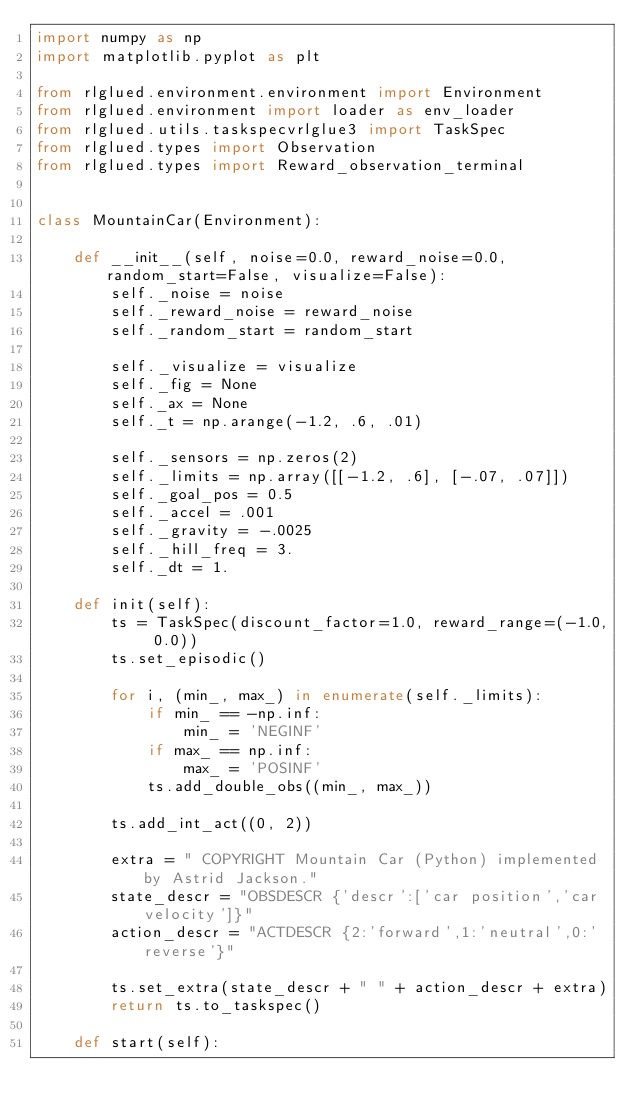<code> <loc_0><loc_0><loc_500><loc_500><_Python_>import numpy as np
import matplotlib.pyplot as plt

from rlglued.environment.environment import Environment
from rlglued.environment import loader as env_loader
from rlglued.utils.taskspecvrlglue3 import TaskSpec
from rlglued.types import Observation
from rlglued.types import Reward_observation_terminal


class MountainCar(Environment):

    def __init__(self, noise=0.0, reward_noise=0.0, random_start=False, visualize=False):
        self._noise = noise
        self._reward_noise = reward_noise
        self._random_start = random_start

        self._visualize = visualize
        self._fig = None
        self._ax = None
        self._t = np.arange(-1.2, .6, .01)

        self._sensors = np.zeros(2)
        self._limits = np.array([[-1.2, .6], [-.07, .07]])
        self._goal_pos = 0.5
        self._accel = .001
        self._gravity = -.0025
        self._hill_freq = 3.
        self._dt = 1.

    def init(self):
        ts = TaskSpec(discount_factor=1.0, reward_range=(-1.0, 0.0))
        ts.set_episodic()

        for i, (min_, max_) in enumerate(self._limits):
            if min_ == -np.inf:
                min_ = 'NEGINF'
            if max_ == np.inf:
                max_ = 'POSINF'
            ts.add_double_obs((min_, max_))

        ts.add_int_act((0, 2))

        extra = " COPYRIGHT Mountain Car (Python) implemented by Astrid Jackson."
        state_descr = "OBSDESCR {'descr':['car position','car velocity']}"
        action_descr = "ACTDESCR {2:'forward',1:'neutral',0:'reverse'}"

        ts.set_extra(state_descr + " " + action_descr + extra)
        return ts.to_taskspec()

    def start(self):</code> 